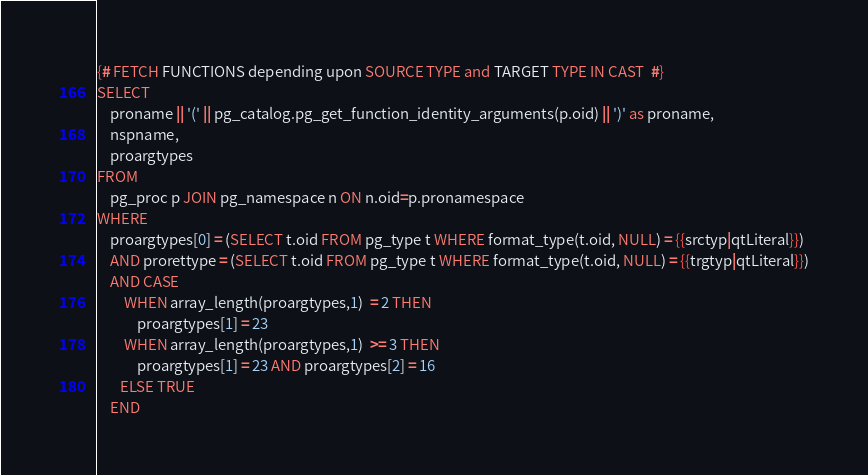<code> <loc_0><loc_0><loc_500><loc_500><_SQL_>{# FETCH FUNCTIONS depending upon SOURCE TYPE and TARGET TYPE IN CAST  #}
SELECT
    proname || '(' || pg_catalog.pg_get_function_identity_arguments(p.oid) || ')' as proname,
    nspname,
    proargtypes
FROM
    pg_proc p JOIN pg_namespace n ON n.oid=p.pronamespace
WHERE
    proargtypes[0] = (SELECT t.oid FROM pg_type t WHERE format_type(t.oid, NULL) = {{srctyp|qtLiteral}})
    AND prorettype = (SELECT t.oid FROM pg_type t WHERE format_type(t.oid, NULL) = {{trgtyp|qtLiteral}})
    AND CASE
        WHEN array_length(proargtypes,1)  = 2 THEN
            proargtypes[1] = 23
        WHEN array_length(proargtypes,1)  >= 3 THEN
            proargtypes[1] = 23 AND proargtypes[2] = 16
       ELSE TRUE
    END
</code> 